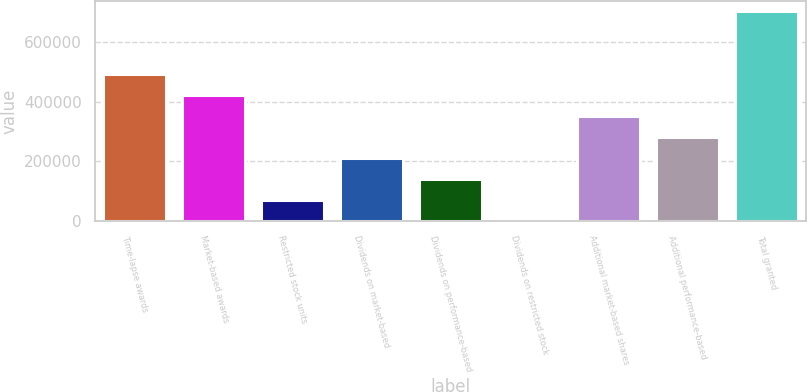<chart> <loc_0><loc_0><loc_500><loc_500><bar_chart><fcel>Time-lapse awards<fcel>Market-based awards<fcel>Restricted stock units<fcel>Dividends on market-based<fcel>Dividends on performance-based<fcel>Dividends on restricted stock<fcel>Additional market-based shares<fcel>Additional performance-based<fcel>Total granted<nl><fcel>492390<fcel>422179<fcel>71125.7<fcel>211547<fcel>141336<fcel>915<fcel>351968<fcel>281758<fcel>703022<nl></chart> 